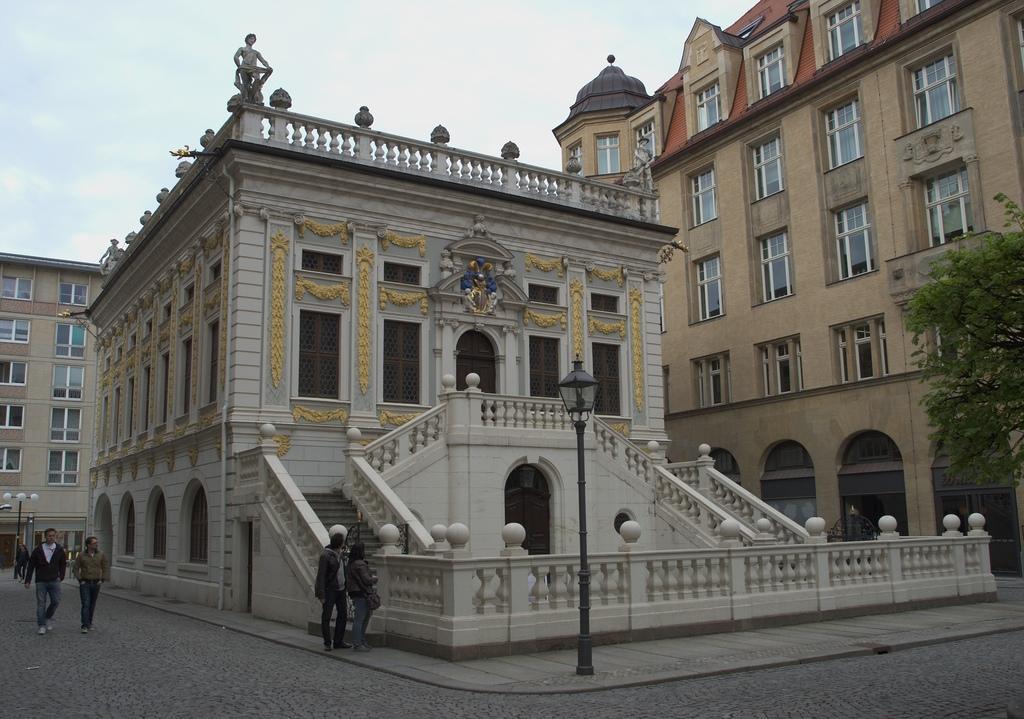In one or two sentences, can you explain what this image depicts? This picture shows a few buildings and we see couple of pole lights and few people walking on the road and couple of them standing on the sidewalk and we see a tree and we see a statue on the building and a blue cloudy Sky. 